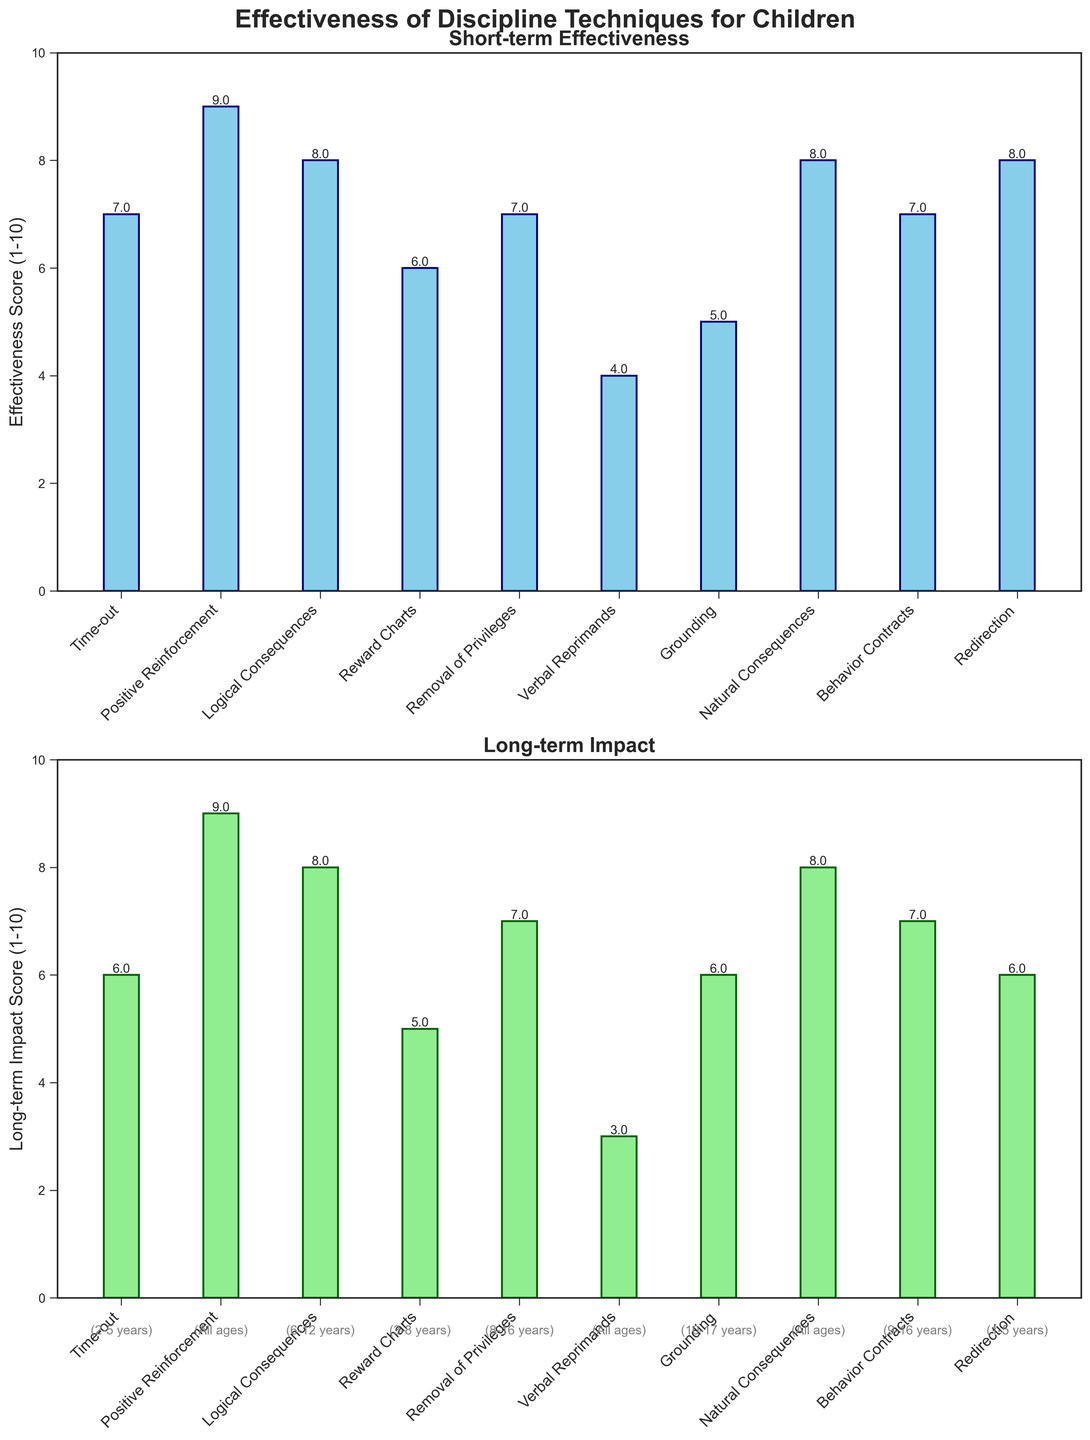Which discipline technique has the highest short-term effectiveness score? The highest short-term effectiveness score is identified by checking the bar with the greatest height in the first subplot. "Positive Reinforcement" has the highest bar.
Answer: Positive Reinforcement Which technique shows the lowest long-term impact score? The lowest long-term impact score is identified by checking the shortest bar in the second subplot. "Verbal Reprimands" has the shortest bar.
Answer: Verbal Reprimands How many discipline techniques are considered in this figure? Count the number of bars in either of the subplots since the same techniques are represented in both. There are 10 bars.
Answer: 10 What is the difference in short-term effectiveness scores between "Positive Reinforcement" and "Verbal Reprimands"? Locate the scores for "Positive Reinforcement" (9) and "Verbal Reprimands" (4) in the first subplot, then subtract the lower score from the higher score: 9 - 4.
Answer: 5 Which techniques are shown to be effective in all age groups in terms of long-term impact? Techniques that are effective in all age groups are labeled as such in the figure. "Positive Reinforcement," "Verbal Reprimands," and "Natural Consequences" are shown to be effective for all ages.
Answer: Positive Reinforcement, Verbal Reprimands, Natural Consequences Are there any techniques that have the same short-term effectiveness and long-term impact scores? Compare the short-term and long-term bar heights for each technique. Both "Logical Consequences" and "Natural Consequences" have equal scores (8 and 8, respectively).
Answer: Logical Consequences, Natural Consequences What is the average short-term effectiveness score of techniques used for children aged 8-16 years? Identify the techniques for ages 8-16 ("Removal of Privileges" and "Behavior Contracts"), then calculate the average of their scores: (7 + 7) / 2 = 7.
Answer: 7 Which technique has the highest discrepancy between its short-term effectiveness and long-term impact scores? Calculate the discrepancy by subtracting long-term impact from short-term effectiveness for each technique, and find the maximum value. "Verbal Reprimands" has the largest difference (4 - 3 = 1).
Answer: Verbal Reprimands 